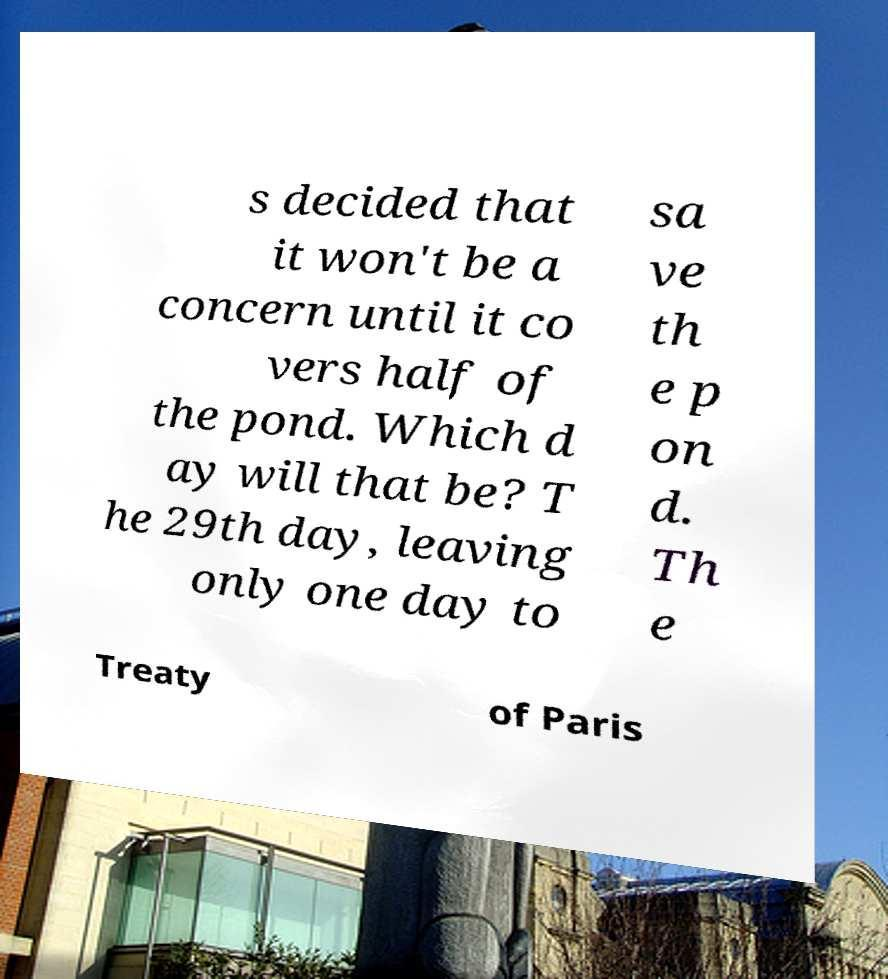Could you extract and type out the text from this image? s decided that it won't be a concern until it co vers half of the pond. Which d ay will that be? T he 29th day, leaving only one day to sa ve th e p on d. Th e Treaty of Paris 